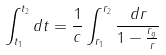Convert formula to latex. <formula><loc_0><loc_0><loc_500><loc_500>\int _ { t _ { 1 } } ^ { t _ { 2 } } d t = \frac { 1 } { c } \int _ { r _ { 1 } } ^ { r _ { 2 } } \frac { d r } { 1 - \frac { r _ { g } } { r } }</formula> 